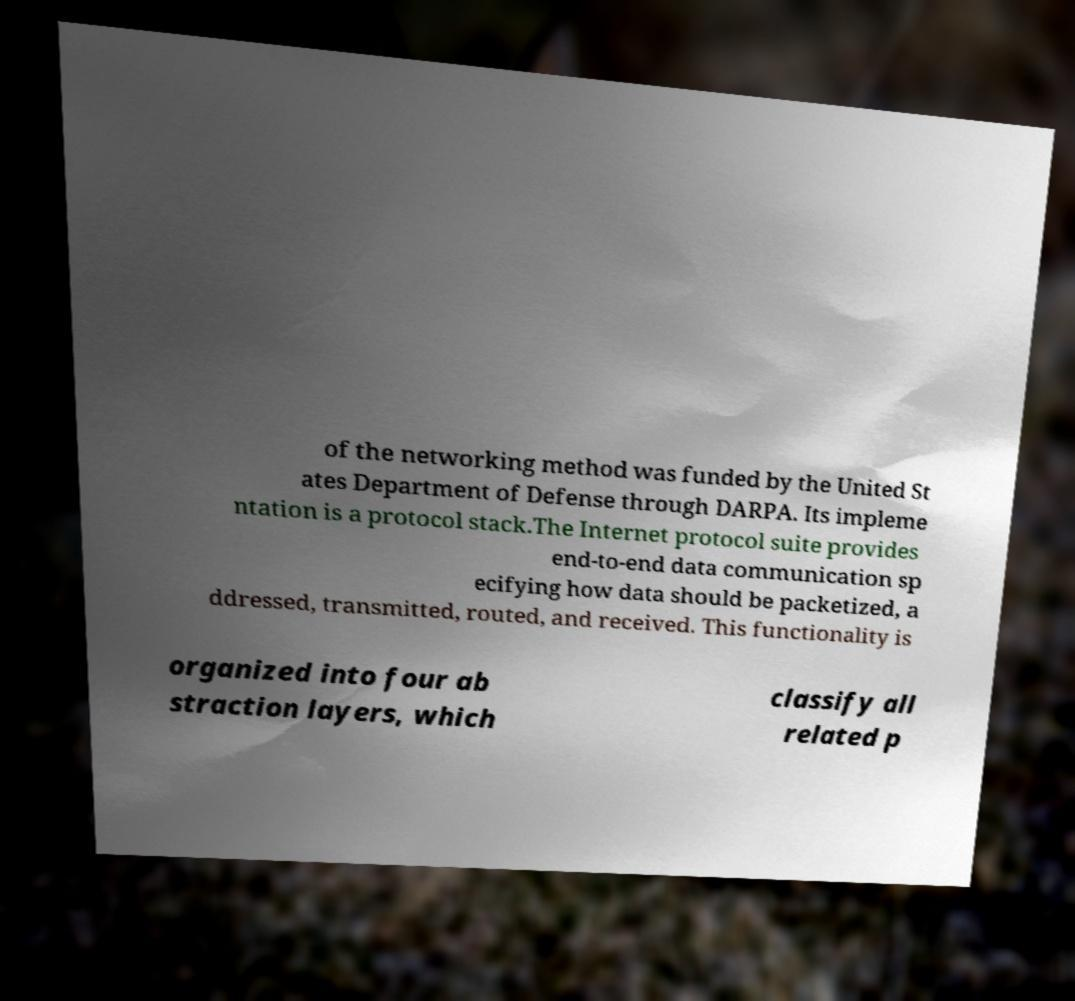Please identify and transcribe the text found in this image. of the networking method was funded by the United St ates Department of Defense through DARPA. Its impleme ntation is a protocol stack.The Internet protocol suite provides end-to-end data communication sp ecifying how data should be packetized, a ddressed, transmitted, routed, and received. This functionality is organized into four ab straction layers, which classify all related p 